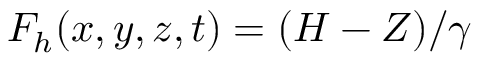Convert formula to latex. <formula><loc_0><loc_0><loc_500><loc_500>F _ { h } ( x , y , z , t ) = ( H - Z ) / \gamma</formula> 